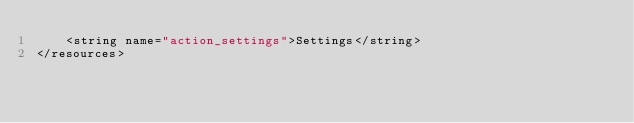Convert code to text. <code><loc_0><loc_0><loc_500><loc_500><_XML_>    <string name="action_settings">Settings</string>
</resources>
</code> 